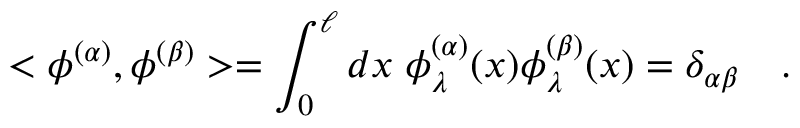<formula> <loc_0><loc_0><loc_500><loc_500>< \phi ^ { ( \alpha ) } , \phi ^ { ( \beta ) } > = \int _ { 0 } ^ { \ell } d x \, \phi _ { \lambda } ^ { ( \alpha ) } ( x ) \phi _ { \lambda } ^ { ( \beta ) } ( x ) = \delta _ { \alpha \beta } \quad .</formula> 